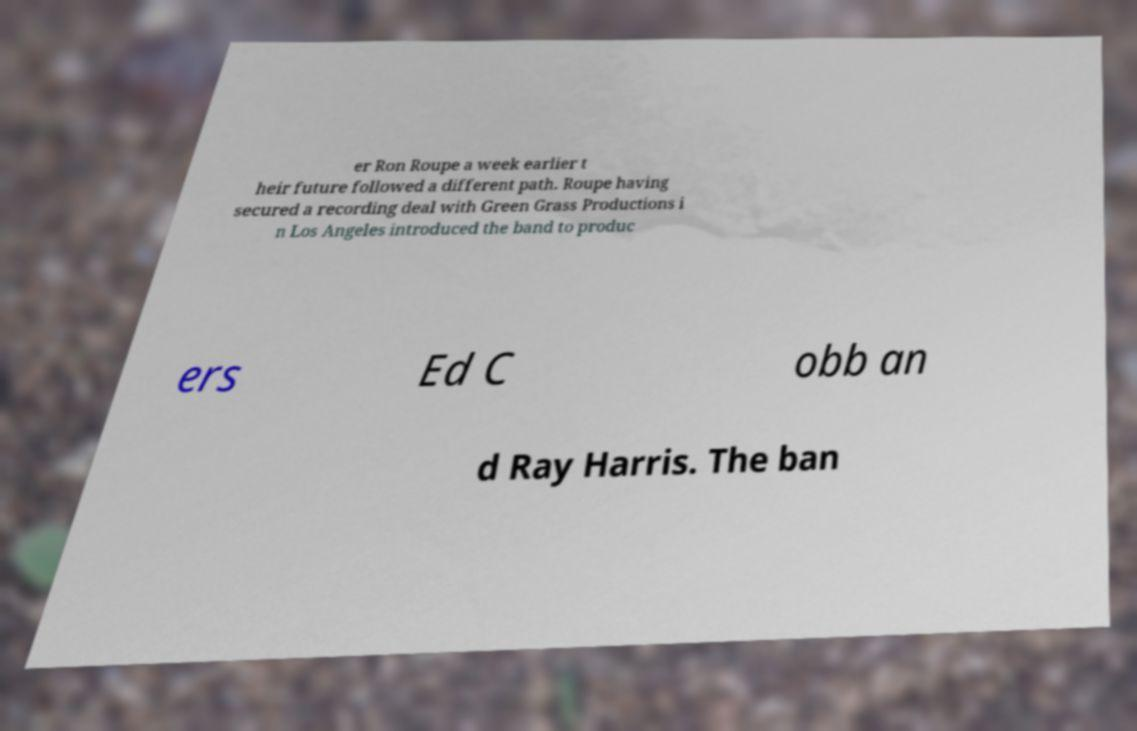What messages or text are displayed in this image? I need them in a readable, typed format. er Ron Roupe a week earlier t heir future followed a different path. Roupe having secured a recording deal with Green Grass Productions i n Los Angeles introduced the band to produc ers Ed C obb an d Ray Harris. The ban 